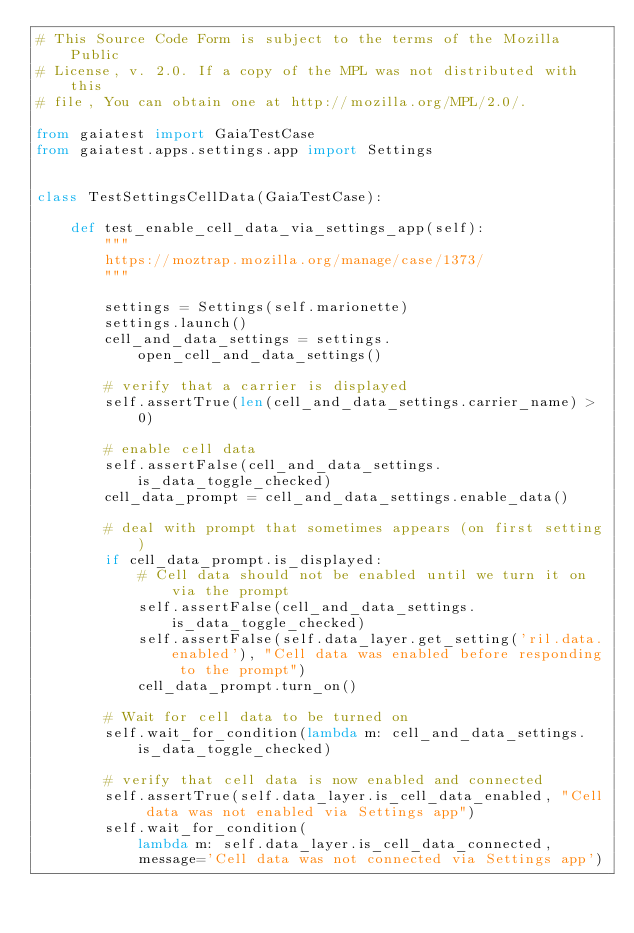Convert code to text. <code><loc_0><loc_0><loc_500><loc_500><_Python_># This Source Code Form is subject to the terms of the Mozilla Public
# License, v. 2.0. If a copy of the MPL was not distributed with this
# file, You can obtain one at http://mozilla.org/MPL/2.0/.

from gaiatest import GaiaTestCase
from gaiatest.apps.settings.app import Settings


class TestSettingsCellData(GaiaTestCase):

    def test_enable_cell_data_via_settings_app(self):
        """
        https://moztrap.mozilla.org/manage/case/1373/
        """

        settings = Settings(self.marionette)
        settings.launch()
        cell_and_data_settings = settings.open_cell_and_data_settings()

        # verify that a carrier is displayed
        self.assertTrue(len(cell_and_data_settings.carrier_name) > 0)

        # enable cell data
        self.assertFalse(cell_and_data_settings.is_data_toggle_checked)
        cell_data_prompt = cell_and_data_settings.enable_data()

        # deal with prompt that sometimes appears (on first setting)
        if cell_data_prompt.is_displayed:
            # Cell data should not be enabled until we turn it on via the prompt
            self.assertFalse(cell_and_data_settings.is_data_toggle_checked)
            self.assertFalse(self.data_layer.get_setting('ril.data.enabled'), "Cell data was enabled before responding to the prompt")
            cell_data_prompt.turn_on()

        # Wait for cell data to be turned on
        self.wait_for_condition(lambda m: cell_and_data_settings.is_data_toggle_checked)

        # verify that cell data is now enabled and connected
        self.assertTrue(self.data_layer.is_cell_data_enabled, "Cell data was not enabled via Settings app")
        self.wait_for_condition(
            lambda m: self.data_layer.is_cell_data_connected,
            message='Cell data was not connected via Settings app')
</code> 